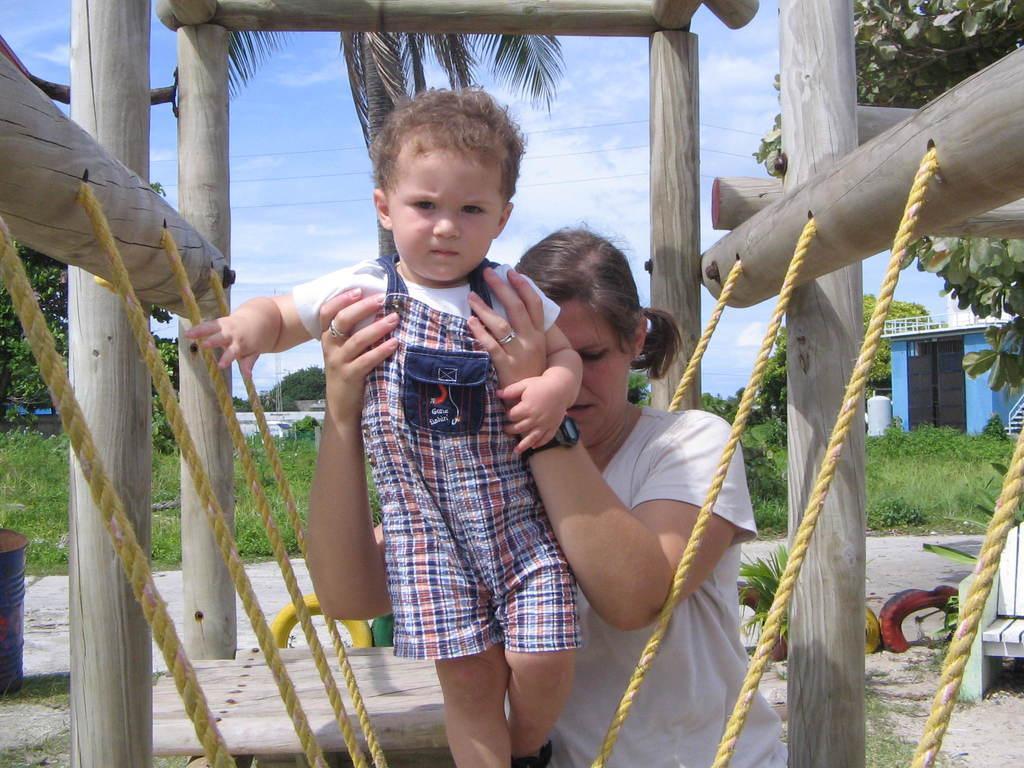Can you describe this image briefly? In this image we can see a woman holding a child, wooden fence, buildings, houseplants, bins, chairs, shed, electric cables, bushes, trees and sky with clouds. 